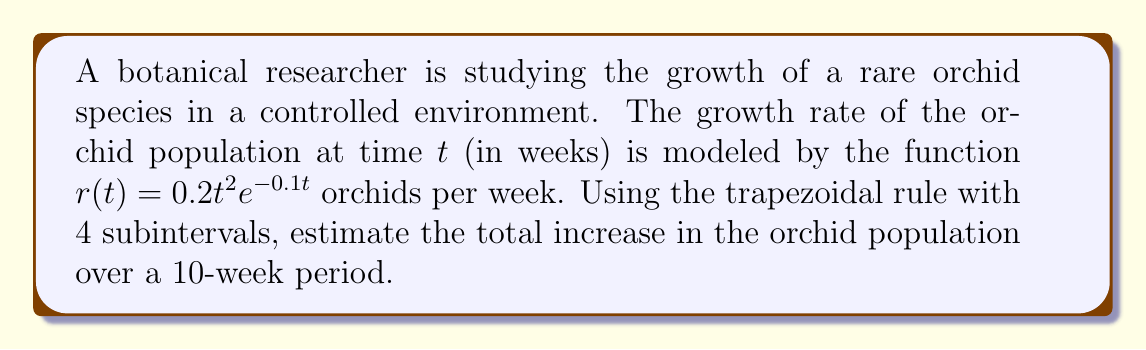Provide a solution to this math problem. To solve this problem, we'll use the trapezoidal rule for numerical integration. The steps are as follows:

1) The total increase in population is given by the integral of the growth rate function:

   $$\int_0^{10} r(t) dt = \int_0^{10} 0.2t^2e^{-0.1t} dt$$

2) We'll use the trapezoidal rule with 4 subintervals. The formula is:

   $$\int_a^b f(x) dx \approx \frac{h}{2}[f(x_0) + 2f(x_1) + 2f(x_2) + 2f(x_3) + f(x_4)]$$

   where $h = \frac{b-a}{n}$, $n$ is the number of subintervals, and $x_i = a + ih$.

3) In our case, $a=0$, $b=10$, and $n=4$. So, $h = \frac{10-0}{4} = 2.5$.

4) We need to evaluate $r(t)$ at $t = 0, 2.5, 5, 7.5,$ and $10$:

   $r(0) = 0.2(0)^2e^{-0.1(0)} = 0$
   $r(2.5) = 0.2(2.5)^2e^{-0.1(2.5)} \approx 1.0373$
   $r(5) = 0.2(5)^2e^{-0.1(5)} \approx 3.0344$
   $r(7.5) = 0.2(7.5)^2e^{-0.1(7.5)} \approx 5.0257$
   $r(10) = 0.2(10)^2e^{-0.1(10)} \approx 6.7032$

5) Applying the trapezoidal rule:

   $$\int_0^{10} r(t) dt \approx \frac{2.5}{2}[0 + 2(1.0373) + 2(3.0344) + 2(5.0257) + 6.7032]$$
   $$= 1.25[0 + 2.0746 + 6.0688 + 10.0514 + 6.7032]$$
   $$= 1.25(24.8980) = 31.1225$$

Therefore, the estimated total increase in the orchid population over a 10-week period is approximately 31.1225 orchids.
Answer: 31.1225 orchids 